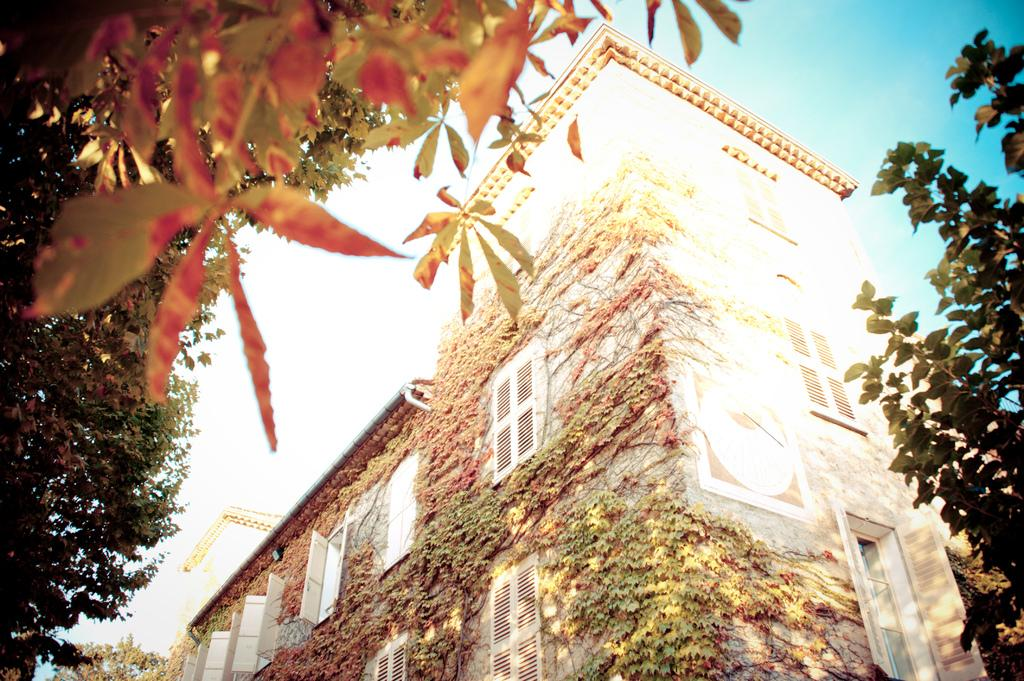What is the main subject in the center of the image? There is a building in the center of the image. What can be seen in the background of the image? There are trees and the sky visible in the background of the image. What type of jam is being spread on the record in the image? There is no jam or record present in the image; it only features a building and background elements. 